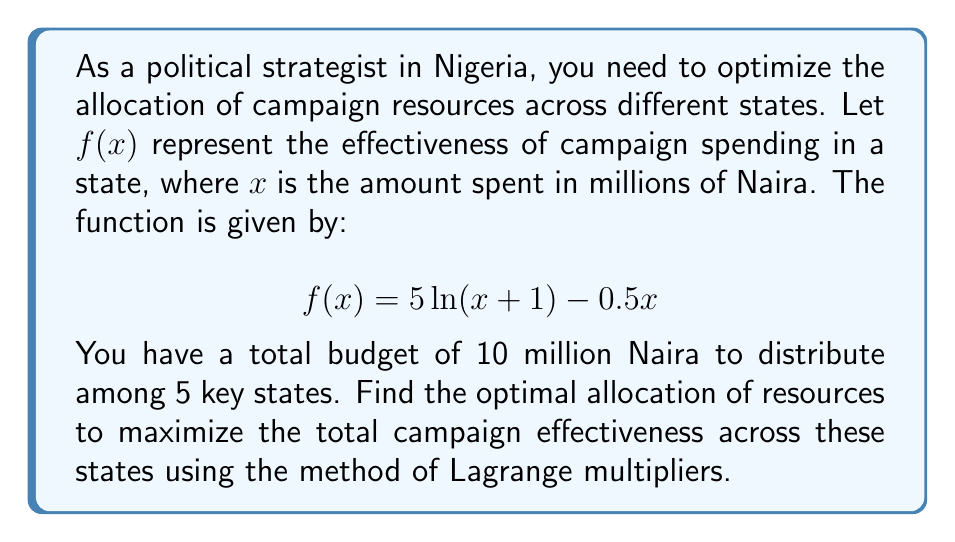Teach me how to tackle this problem. To solve this optimization problem, we'll use the method of Lagrange multipliers:

1) Let $x_1, x_2, x_3, x_4, x_5$ represent the amount spent in each of the 5 states.

2) Our objective function is:
   $$F(x_1, x_2, x_3, x_4, x_5) = \sum_{i=1}^5 f(x_i) = \sum_{i=1}^5 [5\ln(x_i+1) - 0.5x_i]$$

3) The constraint is:
   $$g(x_1, x_2, x_3, x_4, x_5) = x_1 + x_2 + x_3 + x_4 + x_5 - 10 = 0$$

4) We form the Lagrangian:
   $$L(x_1, x_2, x_3, x_4, x_5, \lambda) = F(x_1, x_2, x_3, x_4, x_5) - \lambda g(x_1, x_2, x_3, x_4, x_5)$$

5) Taking partial derivatives and setting them to zero:
   $$\frac{\partial L}{\partial x_i} = \frac{5}{x_i+1} - 0.5 - \lambda = 0 \text{ for } i = 1,2,3,4,5$$
   $$\frac{\partial L}{\partial \lambda} = x_1 + x_2 + x_3 + x_4 + x_5 - 10 = 0$$

6) From the first equation:
   $$\frac{5}{x_i+1} - 0.5 = \lambda$$
   $$x_i = \frac{5}{\lambda+0.5} - 1 \text{ for all } i$$

7) Substituting this into the constraint equation:
   $$5(\frac{5}{\lambda+0.5} - 1) = 10$$
   $$\frac{25}{\lambda+0.5} = 15$$
   $$\lambda = \frac{5}{3} - 0.5 = \frac{5}{6}$$

8) Substituting back:
   $$x_i = \frac{5}{\frac{5}{6}+0.5} - 1 = 2 \text{ for all } i$$

Therefore, the optimal allocation is to spend 2 million Naira in each of the 5 states.
Answer: The optimal allocation is to spend 2 million Naira in each of the 5 states. 